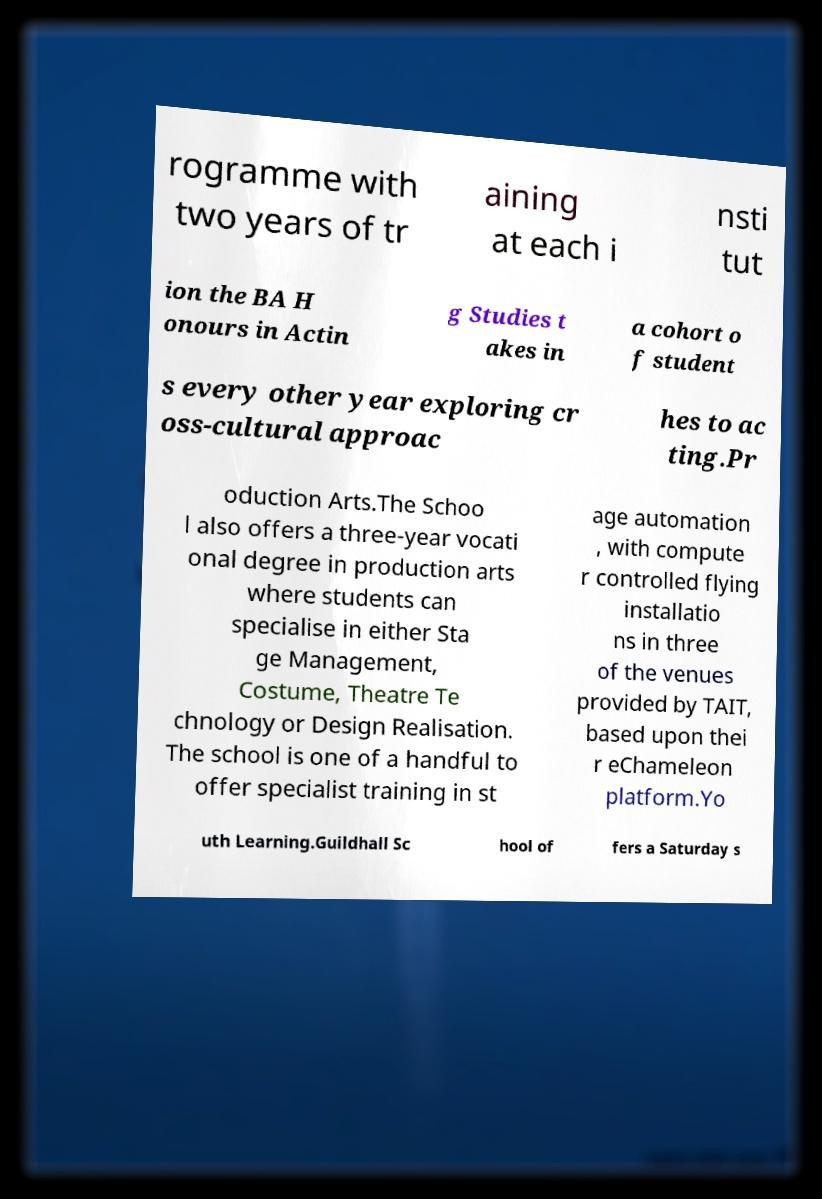For documentation purposes, I need the text within this image transcribed. Could you provide that? rogramme with two years of tr aining at each i nsti tut ion the BA H onours in Actin g Studies t akes in a cohort o f student s every other year exploring cr oss-cultural approac hes to ac ting.Pr oduction Arts.The Schoo l also offers a three-year vocati onal degree in production arts where students can specialise in either Sta ge Management, Costume, Theatre Te chnology or Design Realisation. The school is one of a handful to offer specialist training in st age automation , with compute r controlled flying installatio ns in three of the venues provided by TAIT, based upon thei r eChameleon platform.Yo uth Learning.Guildhall Sc hool of fers a Saturday s 